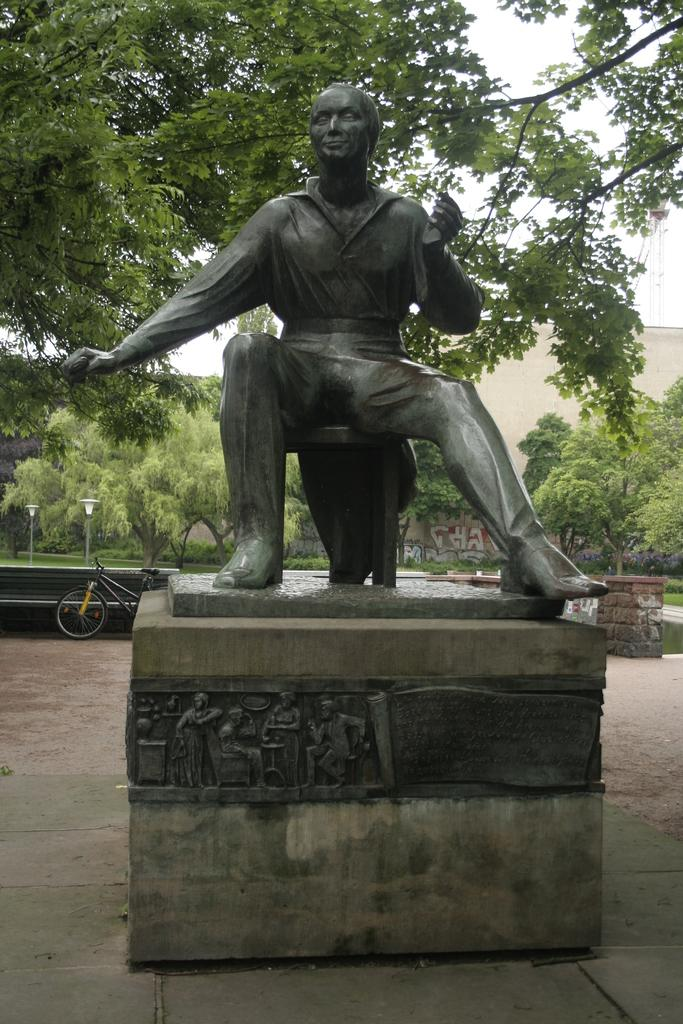What is the main subject in the center of the image? There is a statue in the center of the image. What can be seen in the background of the image? There are trees and a building in the background of the image. What mode of transportation is present in the image? There is a bicycle in the image. What is visible at the bottom of the image? There is a floor visible at the bottom of the image. What type of wine is being served at the play in the image? There is no play or wine present in the image; it features a statue, trees, a building, a bicycle, and a floor. 